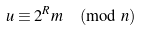<formula> <loc_0><loc_0><loc_500><loc_500>u \equiv 2 ^ { R } m \pmod { n }</formula> 